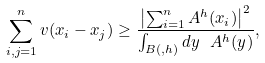<formula> <loc_0><loc_0><loc_500><loc_500>\sum _ { i , j = 1 } ^ { n } v ( x _ { i } - x _ { j } ) \geq \frac { \left | \sum _ { i = 1 } ^ { n } A _ { \L } ^ { h } ( x _ { i } ) \right | ^ { 2 } } { \int _ { B ( \L , h ) } d y \ A _ { \L } ^ { h } ( y ) } ,</formula> 